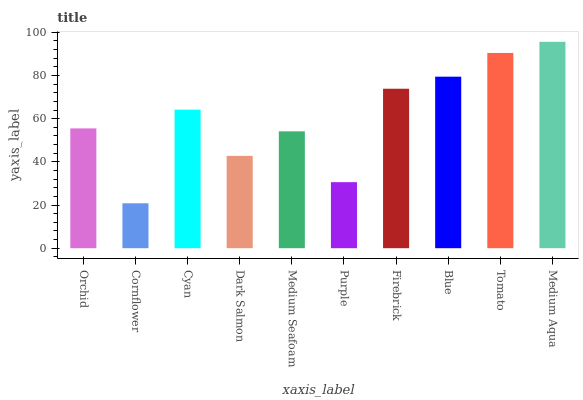Is Cornflower the minimum?
Answer yes or no. Yes. Is Medium Aqua the maximum?
Answer yes or no. Yes. Is Cyan the minimum?
Answer yes or no. No. Is Cyan the maximum?
Answer yes or no. No. Is Cyan greater than Cornflower?
Answer yes or no. Yes. Is Cornflower less than Cyan?
Answer yes or no. Yes. Is Cornflower greater than Cyan?
Answer yes or no. No. Is Cyan less than Cornflower?
Answer yes or no. No. Is Cyan the high median?
Answer yes or no. Yes. Is Orchid the low median?
Answer yes or no. Yes. Is Dark Salmon the high median?
Answer yes or no. No. Is Cyan the low median?
Answer yes or no. No. 